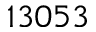Convert formula to latex. <formula><loc_0><loc_0><loc_500><loc_500>1 3 0 5 3</formula> 